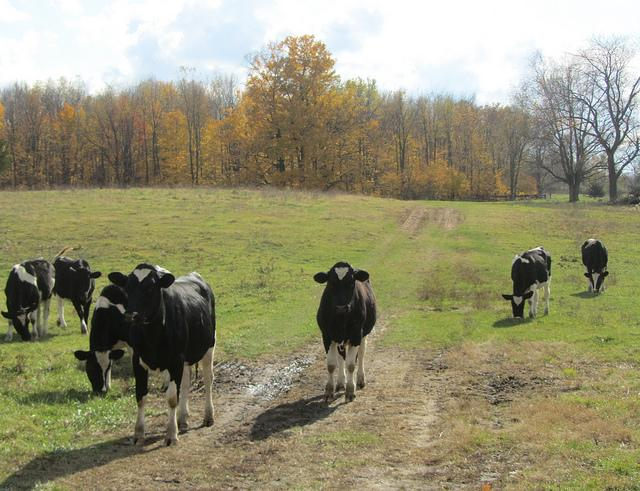What likely made the tracks on the ground? truck 